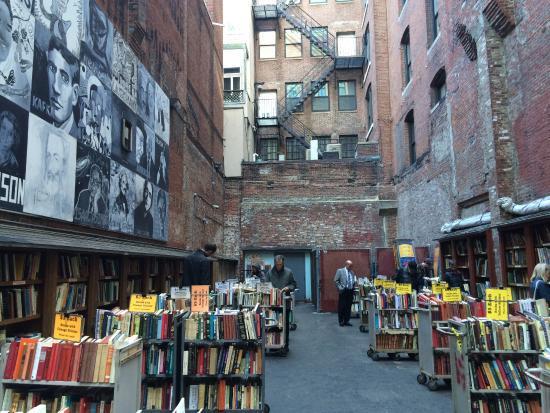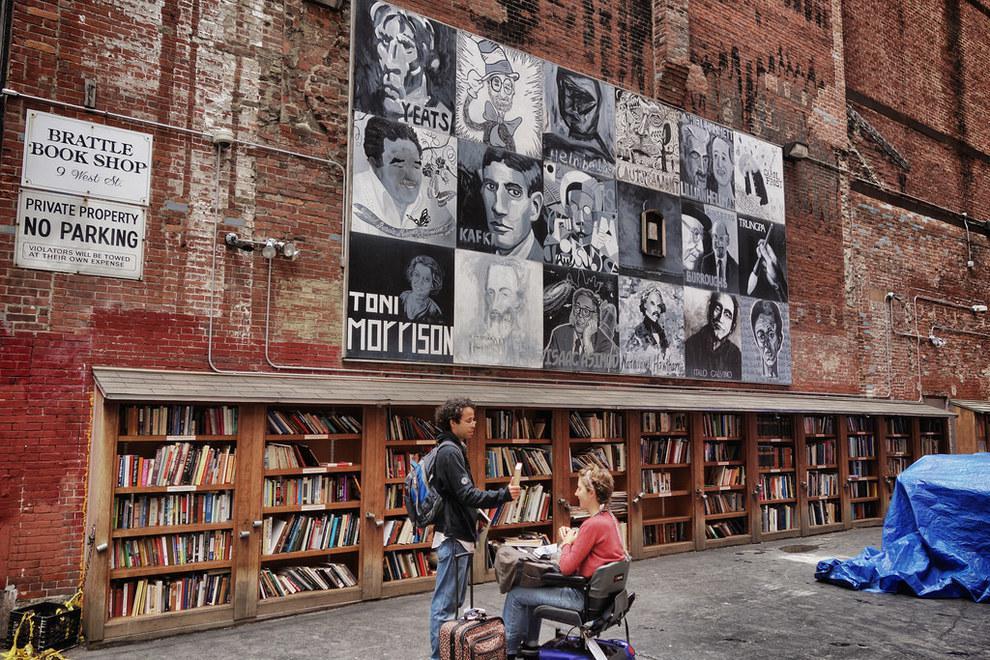The first image is the image on the left, the second image is the image on the right. Assess this claim about the two images: "A man in tan pants is standing up near a building in the image on the right.". Correct or not? Answer yes or no. No. The first image is the image on the left, the second image is the image on the right. Given the left and right images, does the statement "An image shows a yellow sharpened pencil shape above shop windows and below a projecting reddish sign." hold true? Answer yes or no. No. 